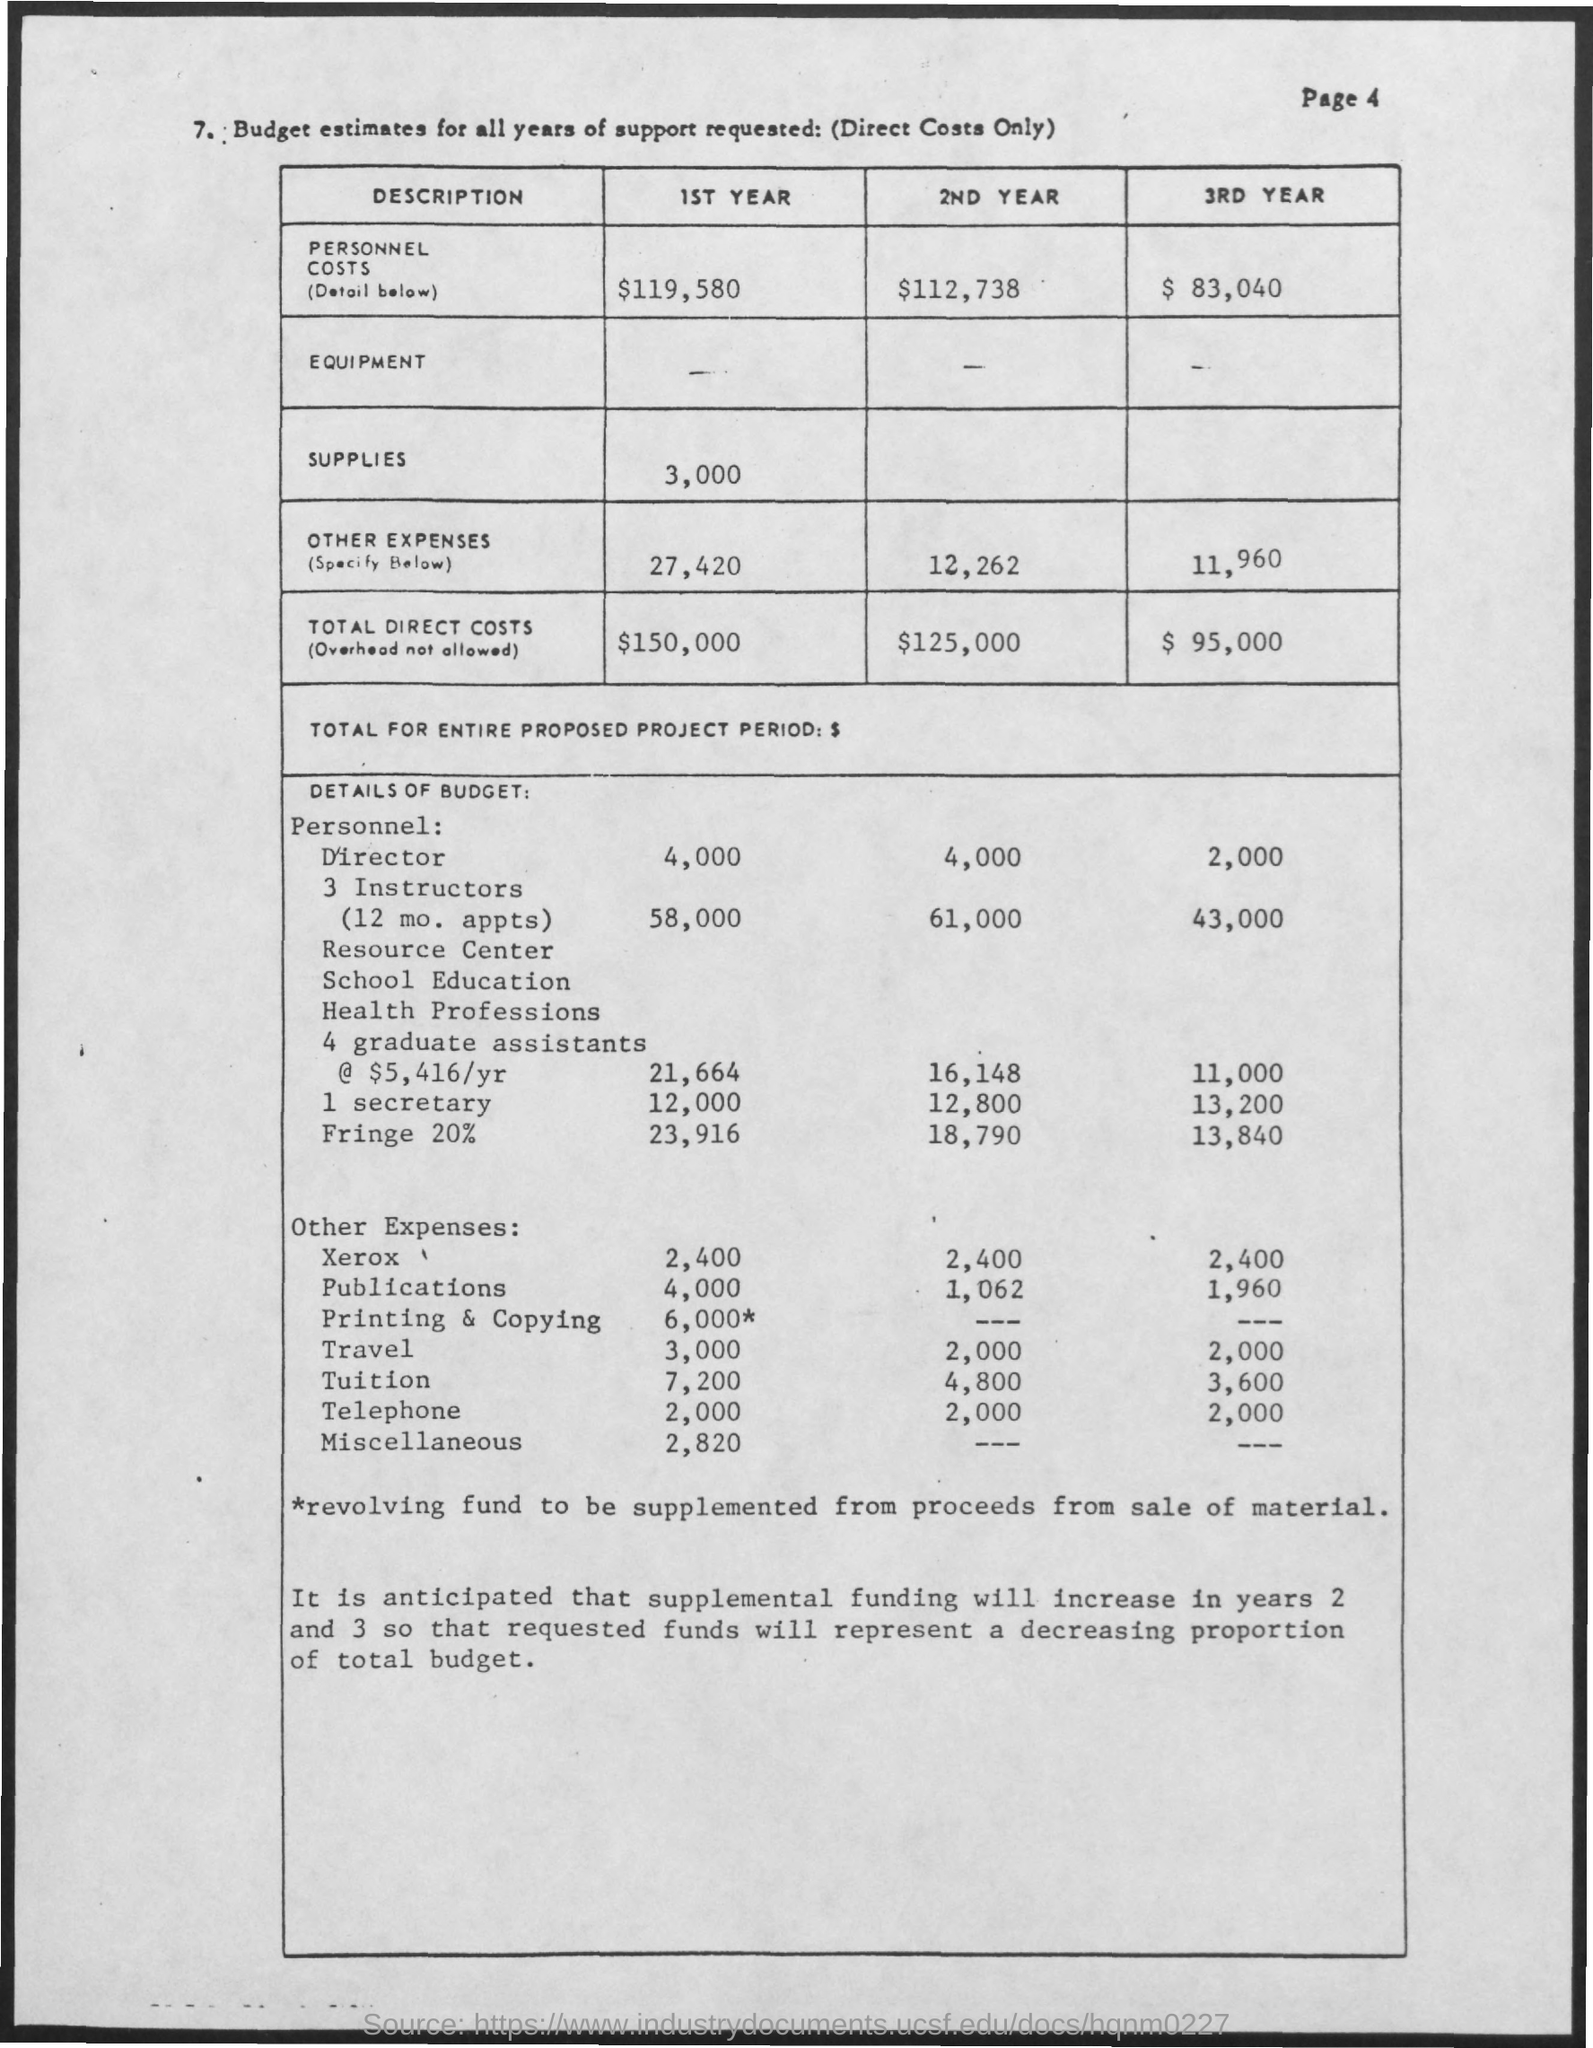Indicate a few pertinent items in this graphic. The table heading, "Budget estimates for all years of support required," provides a clear and concise summary of the information presented in the table. The cost of supplies for the first year is approximately 3,000. The page number is 4, as stated on the page. The total direct costs for the second year are estimated to be $125,000. 